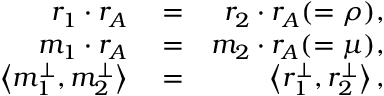Convert formula to latex. <formula><loc_0><loc_0><loc_500><loc_500>\begin{array} { r l r } { r _ { 1 } \cdot r _ { A } } & = } & { r _ { 2 } \cdot r _ { A } ( = \rho ) , } \\ { m _ { 1 } \cdot r _ { A } } & = } & { m _ { 2 } \cdot r _ { A } ( = \mu ) , } \\ { \left < { m _ { 1 } ^ { \perp } , m _ { 2 } ^ { \perp } } \right > } & = } & { \left < { r _ { 1 } ^ { \perp } , r _ { 2 } ^ { \perp } } \right > , } \end{array}</formula> 